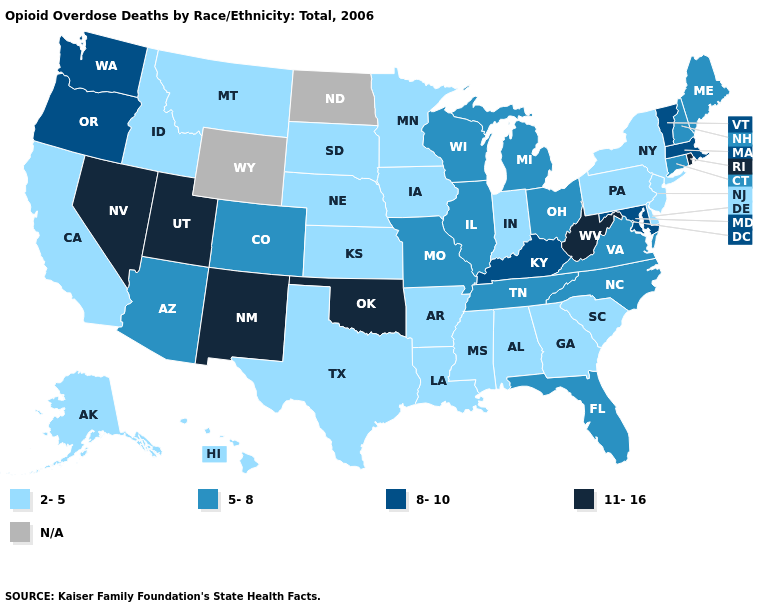Name the states that have a value in the range 2-5?
Give a very brief answer. Alabama, Alaska, Arkansas, California, Delaware, Georgia, Hawaii, Idaho, Indiana, Iowa, Kansas, Louisiana, Minnesota, Mississippi, Montana, Nebraska, New Jersey, New York, Pennsylvania, South Carolina, South Dakota, Texas. What is the value of South Carolina?
Write a very short answer. 2-5. Which states have the lowest value in the South?
Answer briefly. Alabama, Arkansas, Delaware, Georgia, Louisiana, Mississippi, South Carolina, Texas. Among the states that border California , which have the lowest value?
Answer briefly. Arizona. Does Tennessee have the highest value in the South?
Give a very brief answer. No. Name the states that have a value in the range 8-10?
Answer briefly. Kentucky, Maryland, Massachusetts, Oregon, Vermont, Washington. Among the states that border Wisconsin , which have the lowest value?
Answer briefly. Iowa, Minnesota. Among the states that border Idaho , which have the lowest value?
Answer briefly. Montana. Does Rhode Island have the highest value in the Northeast?
Write a very short answer. Yes. Name the states that have a value in the range 11-16?
Short answer required. Nevada, New Mexico, Oklahoma, Rhode Island, Utah, West Virginia. What is the lowest value in states that border North Dakota?
Quick response, please. 2-5. What is the value of Arizona?
Keep it brief. 5-8. Does the first symbol in the legend represent the smallest category?
Keep it brief. Yes. What is the value of Michigan?
Write a very short answer. 5-8. What is the lowest value in the West?
Quick response, please. 2-5. 